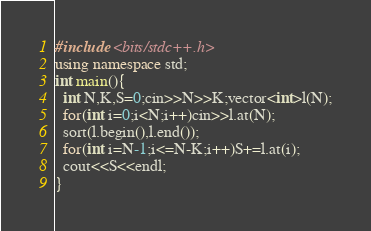<code> <loc_0><loc_0><loc_500><loc_500><_C++_>#include <bits/stdc++.h>
using namespace std;
int main(){
  int N,K,S=0;cin>>N>>K;vector<int>l(N);
  for(int i=0;i<N;i++)cin>>l.at(N);
  sort(l.begin(),l.end());
  for(int i=N-1;i<=N-K;i++)S+=l.at(i);
  cout<<S<<endl;
}</code> 